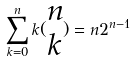<formula> <loc_0><loc_0><loc_500><loc_500>\sum _ { k = 0 } ^ { n } k ( \begin{matrix} n \\ k \end{matrix} ) = n 2 ^ { n - 1 }</formula> 